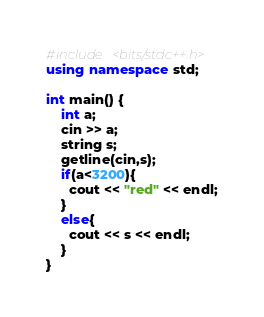Convert code to text. <code><loc_0><loc_0><loc_500><loc_500><_C++_>#include <bits/stdc++.h>
using namespace std;

int main() {
	int a;
    cin >> a;
    string s;
    getline(cin,s);
    if(a<3200){
      cout << "red" << endl;
    }
    else{
      cout << s << endl;
    }
}
</code> 